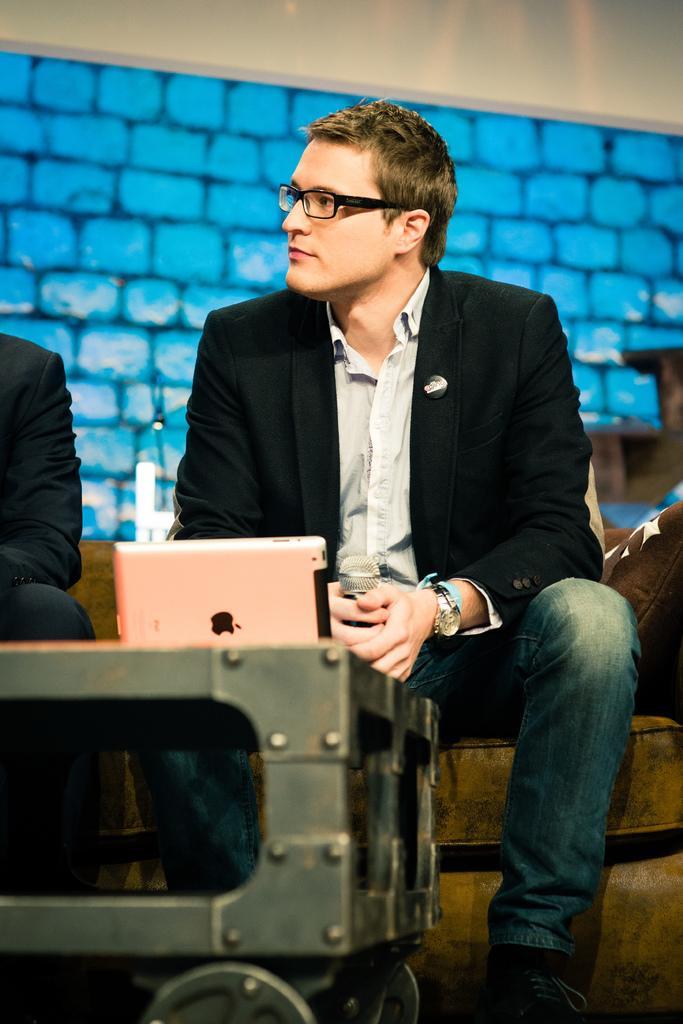Please provide a concise description of this image. These two people are sitting on a couch with pillows. This man is holding a mic. On this table there is an apple device. 